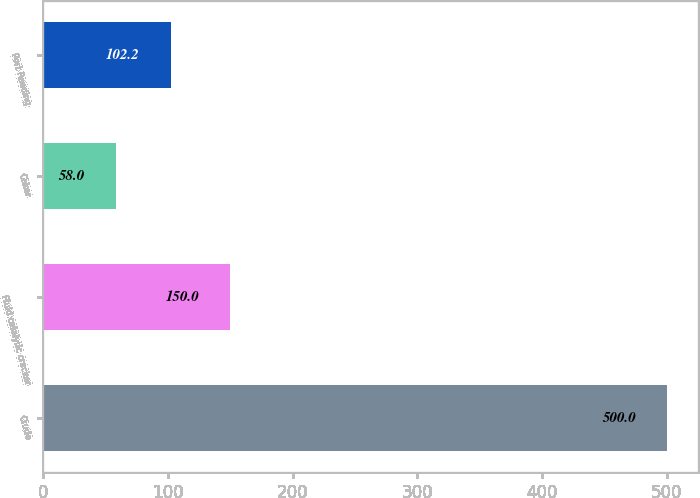Convert chart to OTSL. <chart><loc_0><loc_0><loc_500><loc_500><bar_chart><fcel>Crude<fcel>Fluid catalytic cracker<fcel>Coker<fcel>Port Reading<nl><fcel>500<fcel>150<fcel>58<fcel>102.2<nl></chart> 